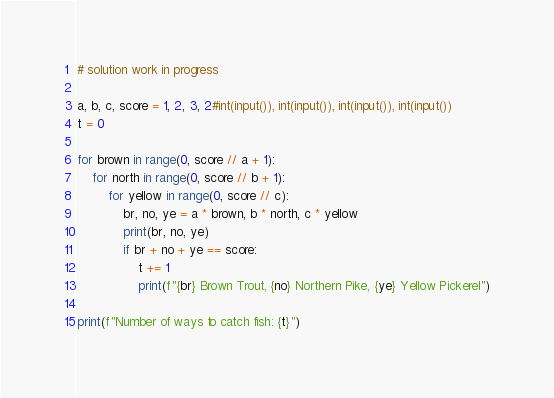<code> <loc_0><loc_0><loc_500><loc_500><_Python_># solution work in progress

a, b, c, score = 1, 2, 3, 2#int(input()), int(input()), int(input()), int(input())
t = 0

for brown in range(0, score // a + 1):
	for north in range(0, score // b + 1):
		for yellow in range(0, score // c):
			br, no, ye = a * brown, b * north, c * yellow
			print(br, no, ye)
			if br + no + ye == score:
				t += 1
				print(f"{br} Brown Trout, {no} Northern Pike, {ye} Yellow Pickerel")

print(f"Number of ways to catch fish: {t}")</code> 